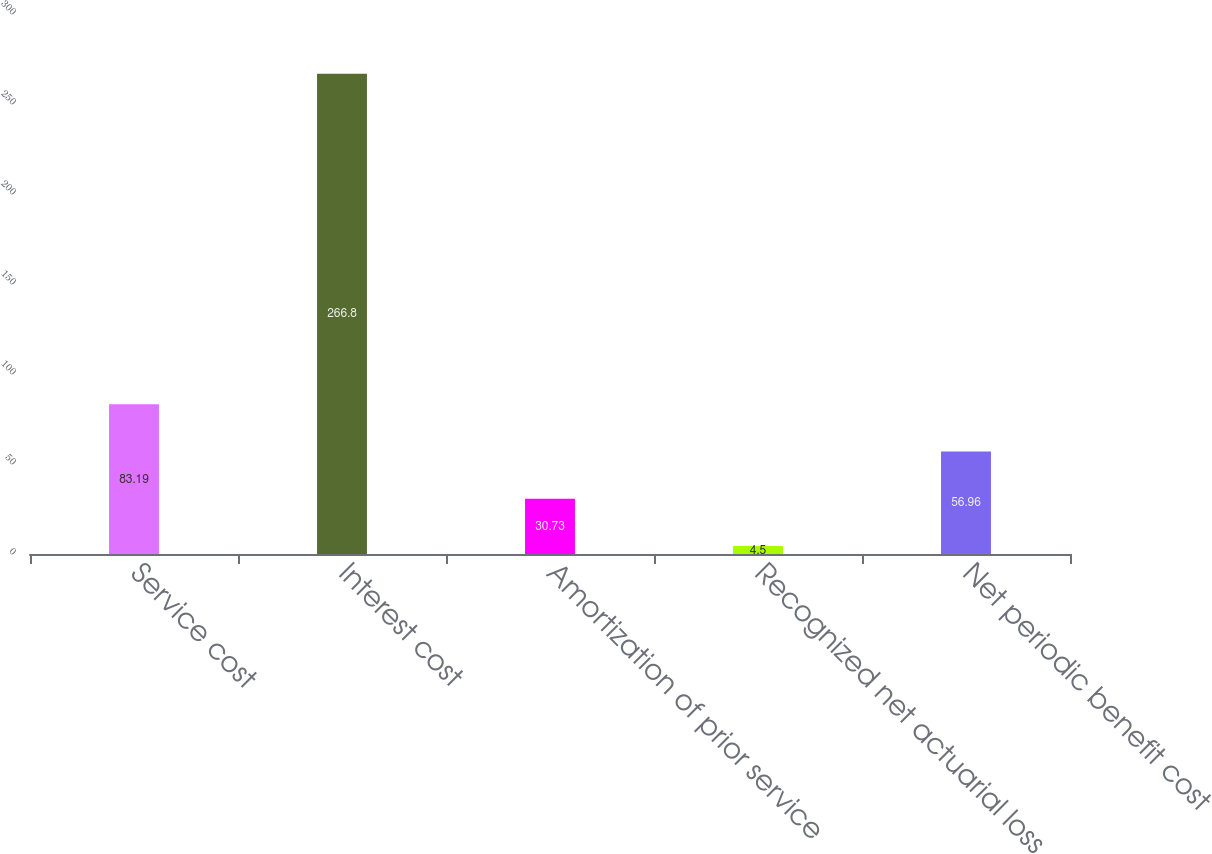Convert chart to OTSL. <chart><loc_0><loc_0><loc_500><loc_500><bar_chart><fcel>Service cost<fcel>Interest cost<fcel>Amortization of prior service<fcel>Recognized net actuarial loss<fcel>Net periodic benefit cost<nl><fcel>83.19<fcel>266.8<fcel>30.73<fcel>4.5<fcel>56.96<nl></chart> 